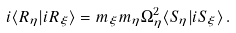Convert formula to latex. <formula><loc_0><loc_0><loc_500><loc_500>i \langle R _ { \eta } | i R _ { \xi } \rangle = m _ { \xi } m _ { \eta } \Omega _ { \eta } ^ { 2 } \langle S _ { \eta } | i S _ { \xi } \rangle \, .</formula> 